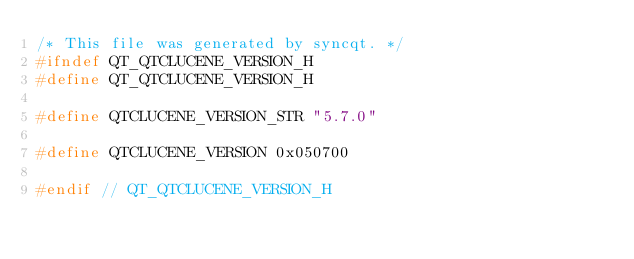<code> <loc_0><loc_0><loc_500><loc_500><_C_>/* This file was generated by syncqt. */
#ifndef QT_QTCLUCENE_VERSION_H
#define QT_QTCLUCENE_VERSION_H

#define QTCLUCENE_VERSION_STR "5.7.0"

#define QTCLUCENE_VERSION 0x050700

#endif // QT_QTCLUCENE_VERSION_H
</code> 